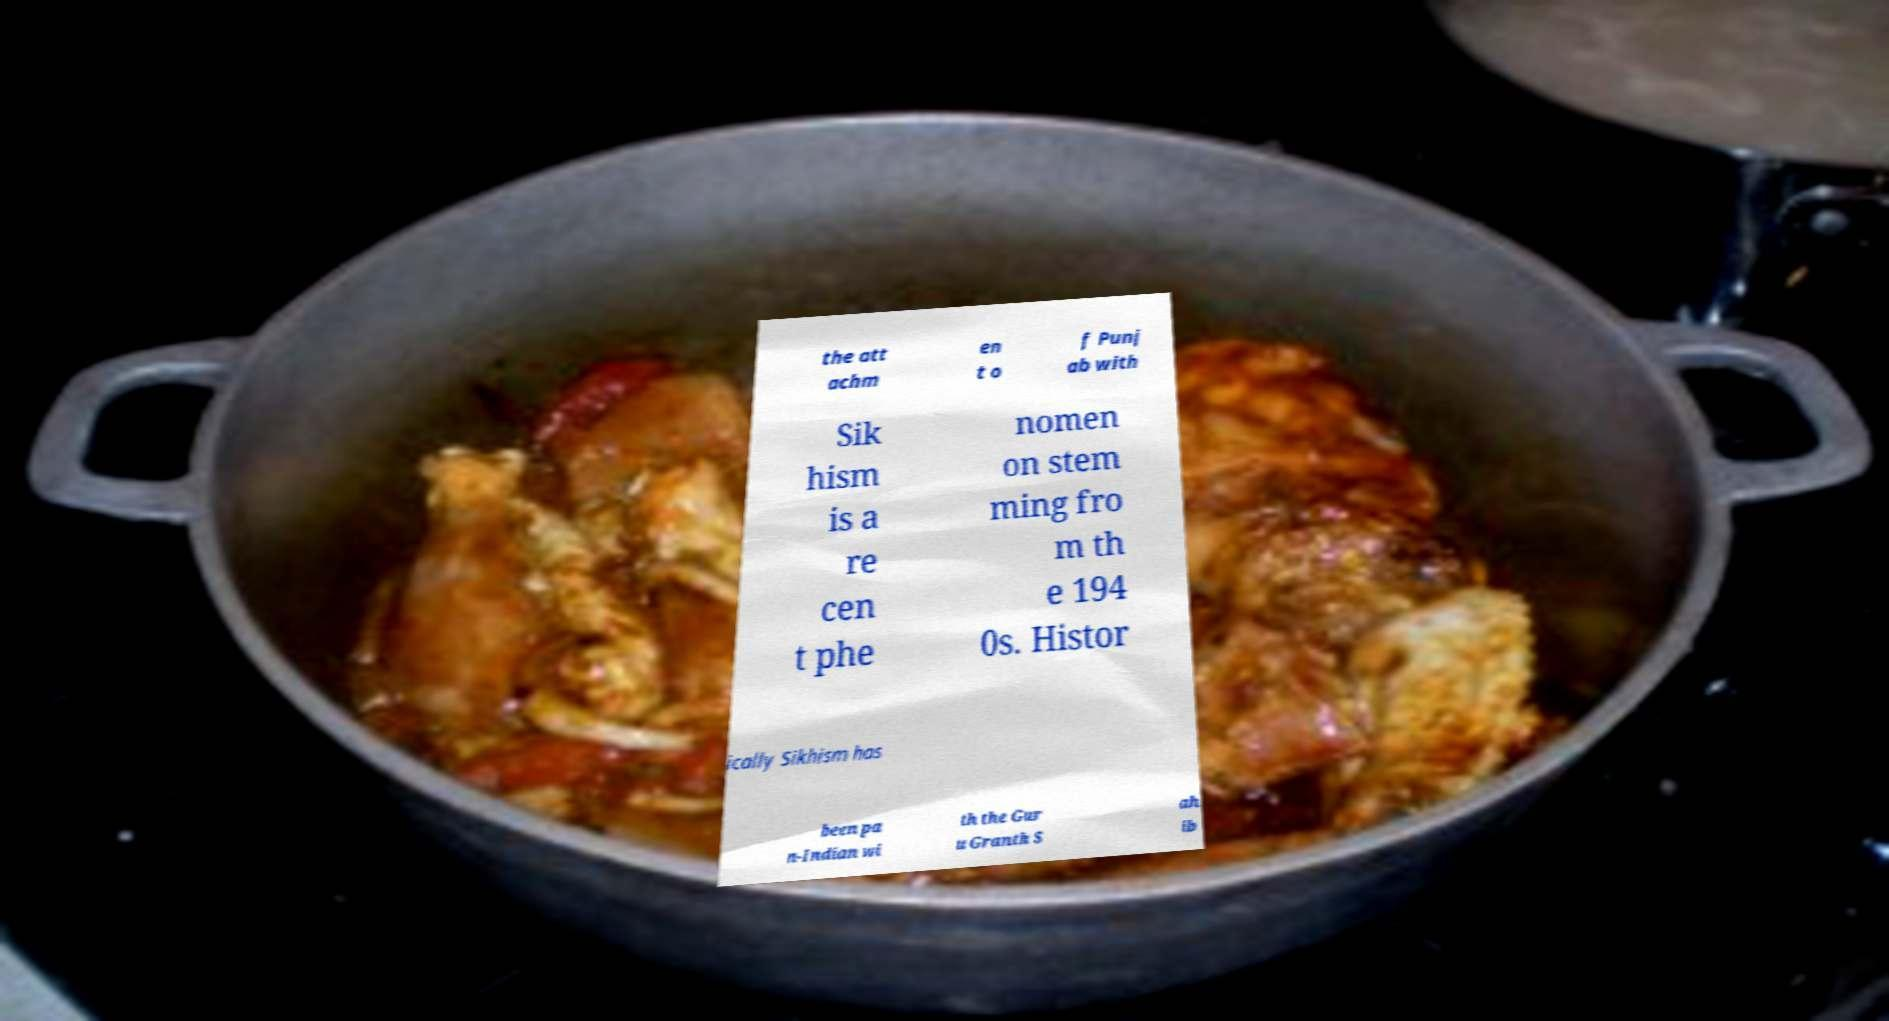What messages or text are displayed in this image? I need them in a readable, typed format. the att achm en t o f Punj ab with Sik hism is a re cen t phe nomen on stem ming fro m th e 194 0s. Histor ically Sikhism has been pa n-Indian wi th the Gur u Granth S ah ib 